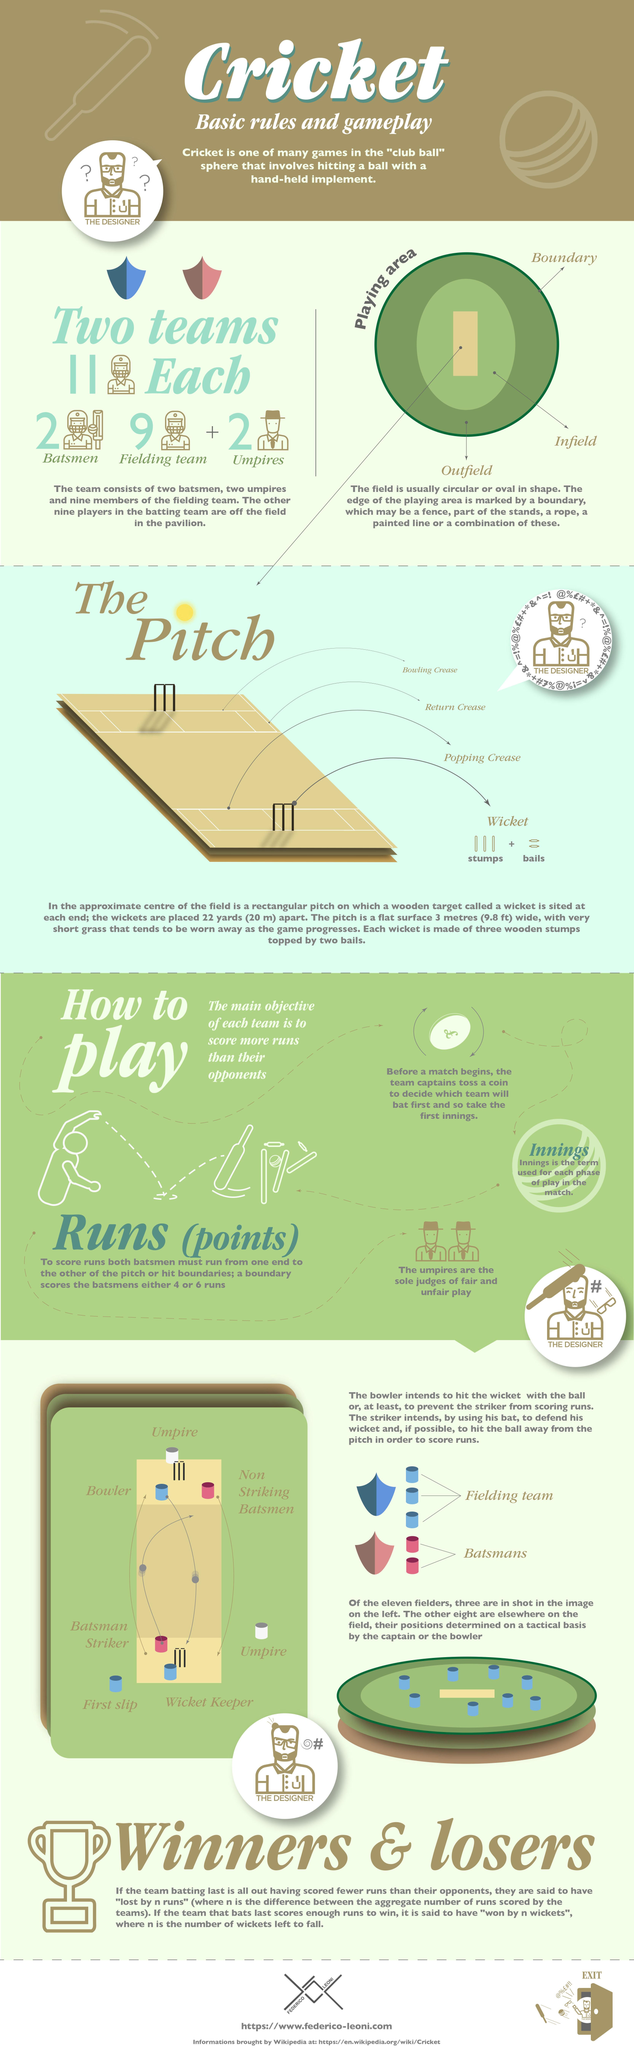List a handful of essential elements in this visual. The area located between the boundary and the infield is known as the outfield. The outer perimeter of the playing field, marked by a rope or painted line, is known as the boundary. The circular or oval area located just outside the playing surface, commonly referred to as the infield, is the official name for this particular region of the field. The rectangular strip at the center of the playing area is known as the pitch. There are 11 players on each team. 